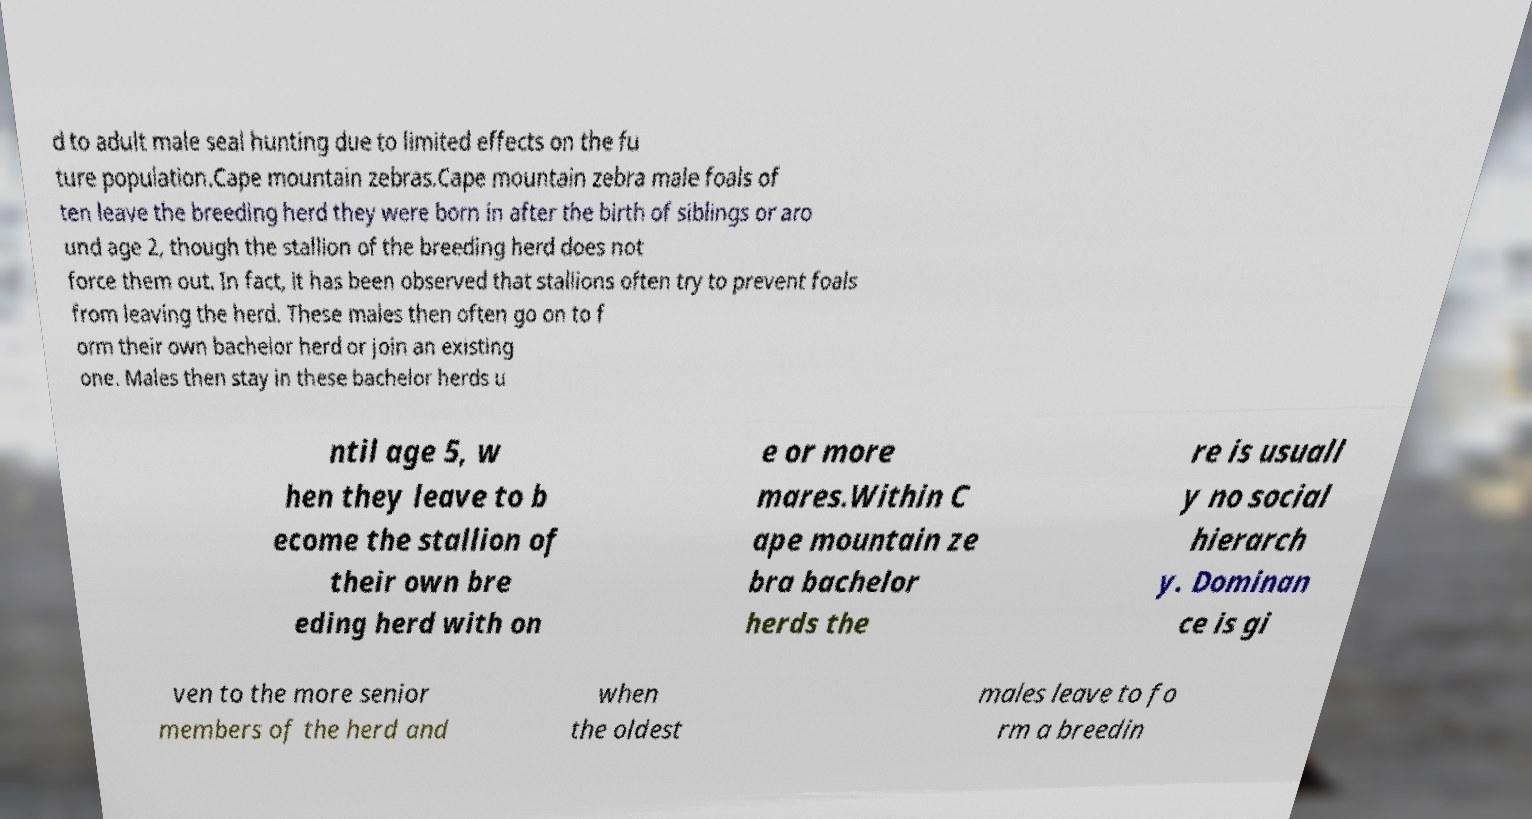I need the written content from this picture converted into text. Can you do that? d to adult male seal hunting due to limited effects on the fu ture population.Cape mountain zebras.Cape mountain zebra male foals of ten leave the breeding herd they were born in after the birth of siblings or aro und age 2, though the stallion of the breeding herd does not force them out. In fact, it has been observed that stallions often try to prevent foals from leaving the herd. These males then often go on to f orm their own bachelor herd or join an existing one. Males then stay in these bachelor herds u ntil age 5, w hen they leave to b ecome the stallion of their own bre eding herd with on e or more mares.Within C ape mountain ze bra bachelor herds the re is usuall y no social hierarch y. Dominan ce is gi ven to the more senior members of the herd and when the oldest males leave to fo rm a breedin 